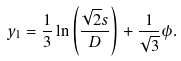<formula> <loc_0><loc_0><loc_500><loc_500>y _ { 1 } = \frac { 1 } { 3 } \ln \left ( \frac { \sqrt { 2 } s } { D } \right ) + \frac { 1 } { \sqrt { 3 } } \phi .</formula> 